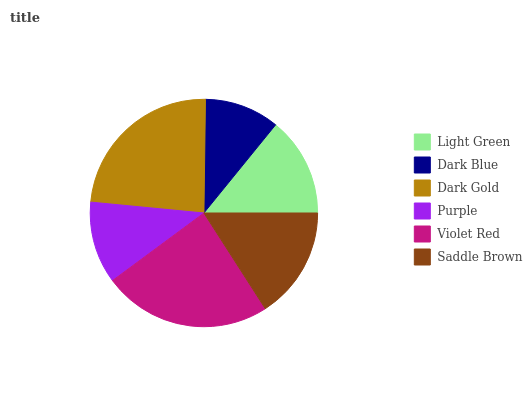Is Dark Blue the minimum?
Answer yes or no. Yes. Is Violet Red the maximum?
Answer yes or no. Yes. Is Dark Gold the minimum?
Answer yes or no. No. Is Dark Gold the maximum?
Answer yes or no. No. Is Dark Gold greater than Dark Blue?
Answer yes or no. Yes. Is Dark Blue less than Dark Gold?
Answer yes or no. Yes. Is Dark Blue greater than Dark Gold?
Answer yes or no. No. Is Dark Gold less than Dark Blue?
Answer yes or no. No. Is Saddle Brown the high median?
Answer yes or no. Yes. Is Light Green the low median?
Answer yes or no. Yes. Is Light Green the high median?
Answer yes or no. No. Is Dark Gold the low median?
Answer yes or no. No. 